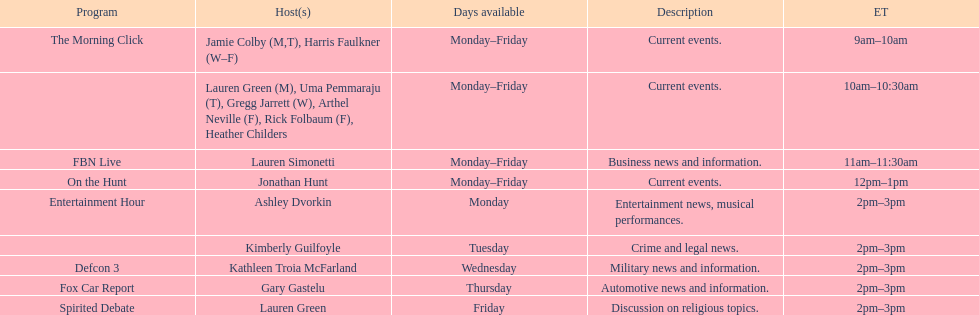How many days during the week does the show fbn live air? 5. 